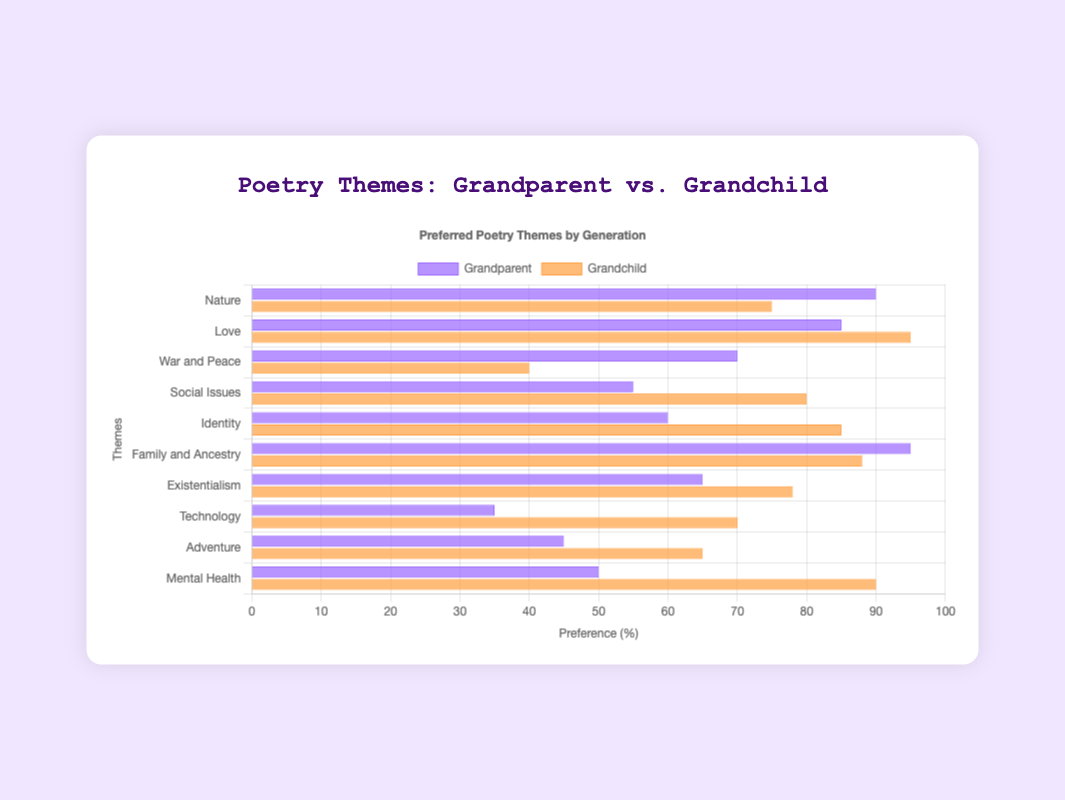Which theme is preferred by both grandparents and grandchildren equally? To determine if there's an equal preference, look for themes where the bar lengths for both grandparents and grandchildren are the same on the horizontal grouped bar chart. There is no theme with equal preference between both generations.
Answer: No theme What is the average preference percentage for grandparents across all themes? Add all the preference percentages for grandparents and divide by the number of themes: (90 + 85 + 70 + 55 + 60 + 95 + 65 + 35 + 45 + 50) / 10 = 65.
Answer: 65 Which theme is least favored by grandparents? Identify the smallest bar for grandparents' preferences, which corresponds to "Technology" with a value of 35.
Answer: Technology For which theme do grandchildren show a higher preference than grandparents? Compare the bar lengths for each theme, identifying those where the grandchild's bar is longer. These themes include Love, Social Issues, Identity, Technology, Adventure, and Mental Health.
Answer: Love, Social Issues, Identity, Technology, Adventure, Mental Health What is the combined preference percentage for grandparents for "Nature" and "Family and Ancestry"? Sum the preferences for "Nature" and "Family and Ancestry" for grandparents: 90 + 95 = 185.
Answer: 185 Among the themes of "Identity," "Adventure," and "Existentialism," which one has the highest preference by grandchildren? Compare the bar lengths for "Identity," "Adventure," and "Existentialism" for grandchildren. "Identity" has the highest value at 85.
Answer: Identity What is the total preference percentage for grandchildren across all themes dealing with modern issues (Social Issues, Technology, Mental Health)? Add the preferences for grandchildren: Social Issues (80) + Technology (70) + Mental Health (90) = 240.
Answer: 240 Which theme is equally important to both grandparents and grandchildren, when considering themes where grandparents have a higher preference? Compare themes where grandparents' preference is higher and see if the difference is relatively small. "Family and Ancestry" shows very close values with preferences of 95 (grandparents) and 88 (grandchildren).
Answer: Family and Ancestry What is the difference in preference for "Love" between grandparents and grandchildren? Subtract the preference of grandparents from grandchildren for the theme "Love": 95 - 85 = 10.
Answer: 10 